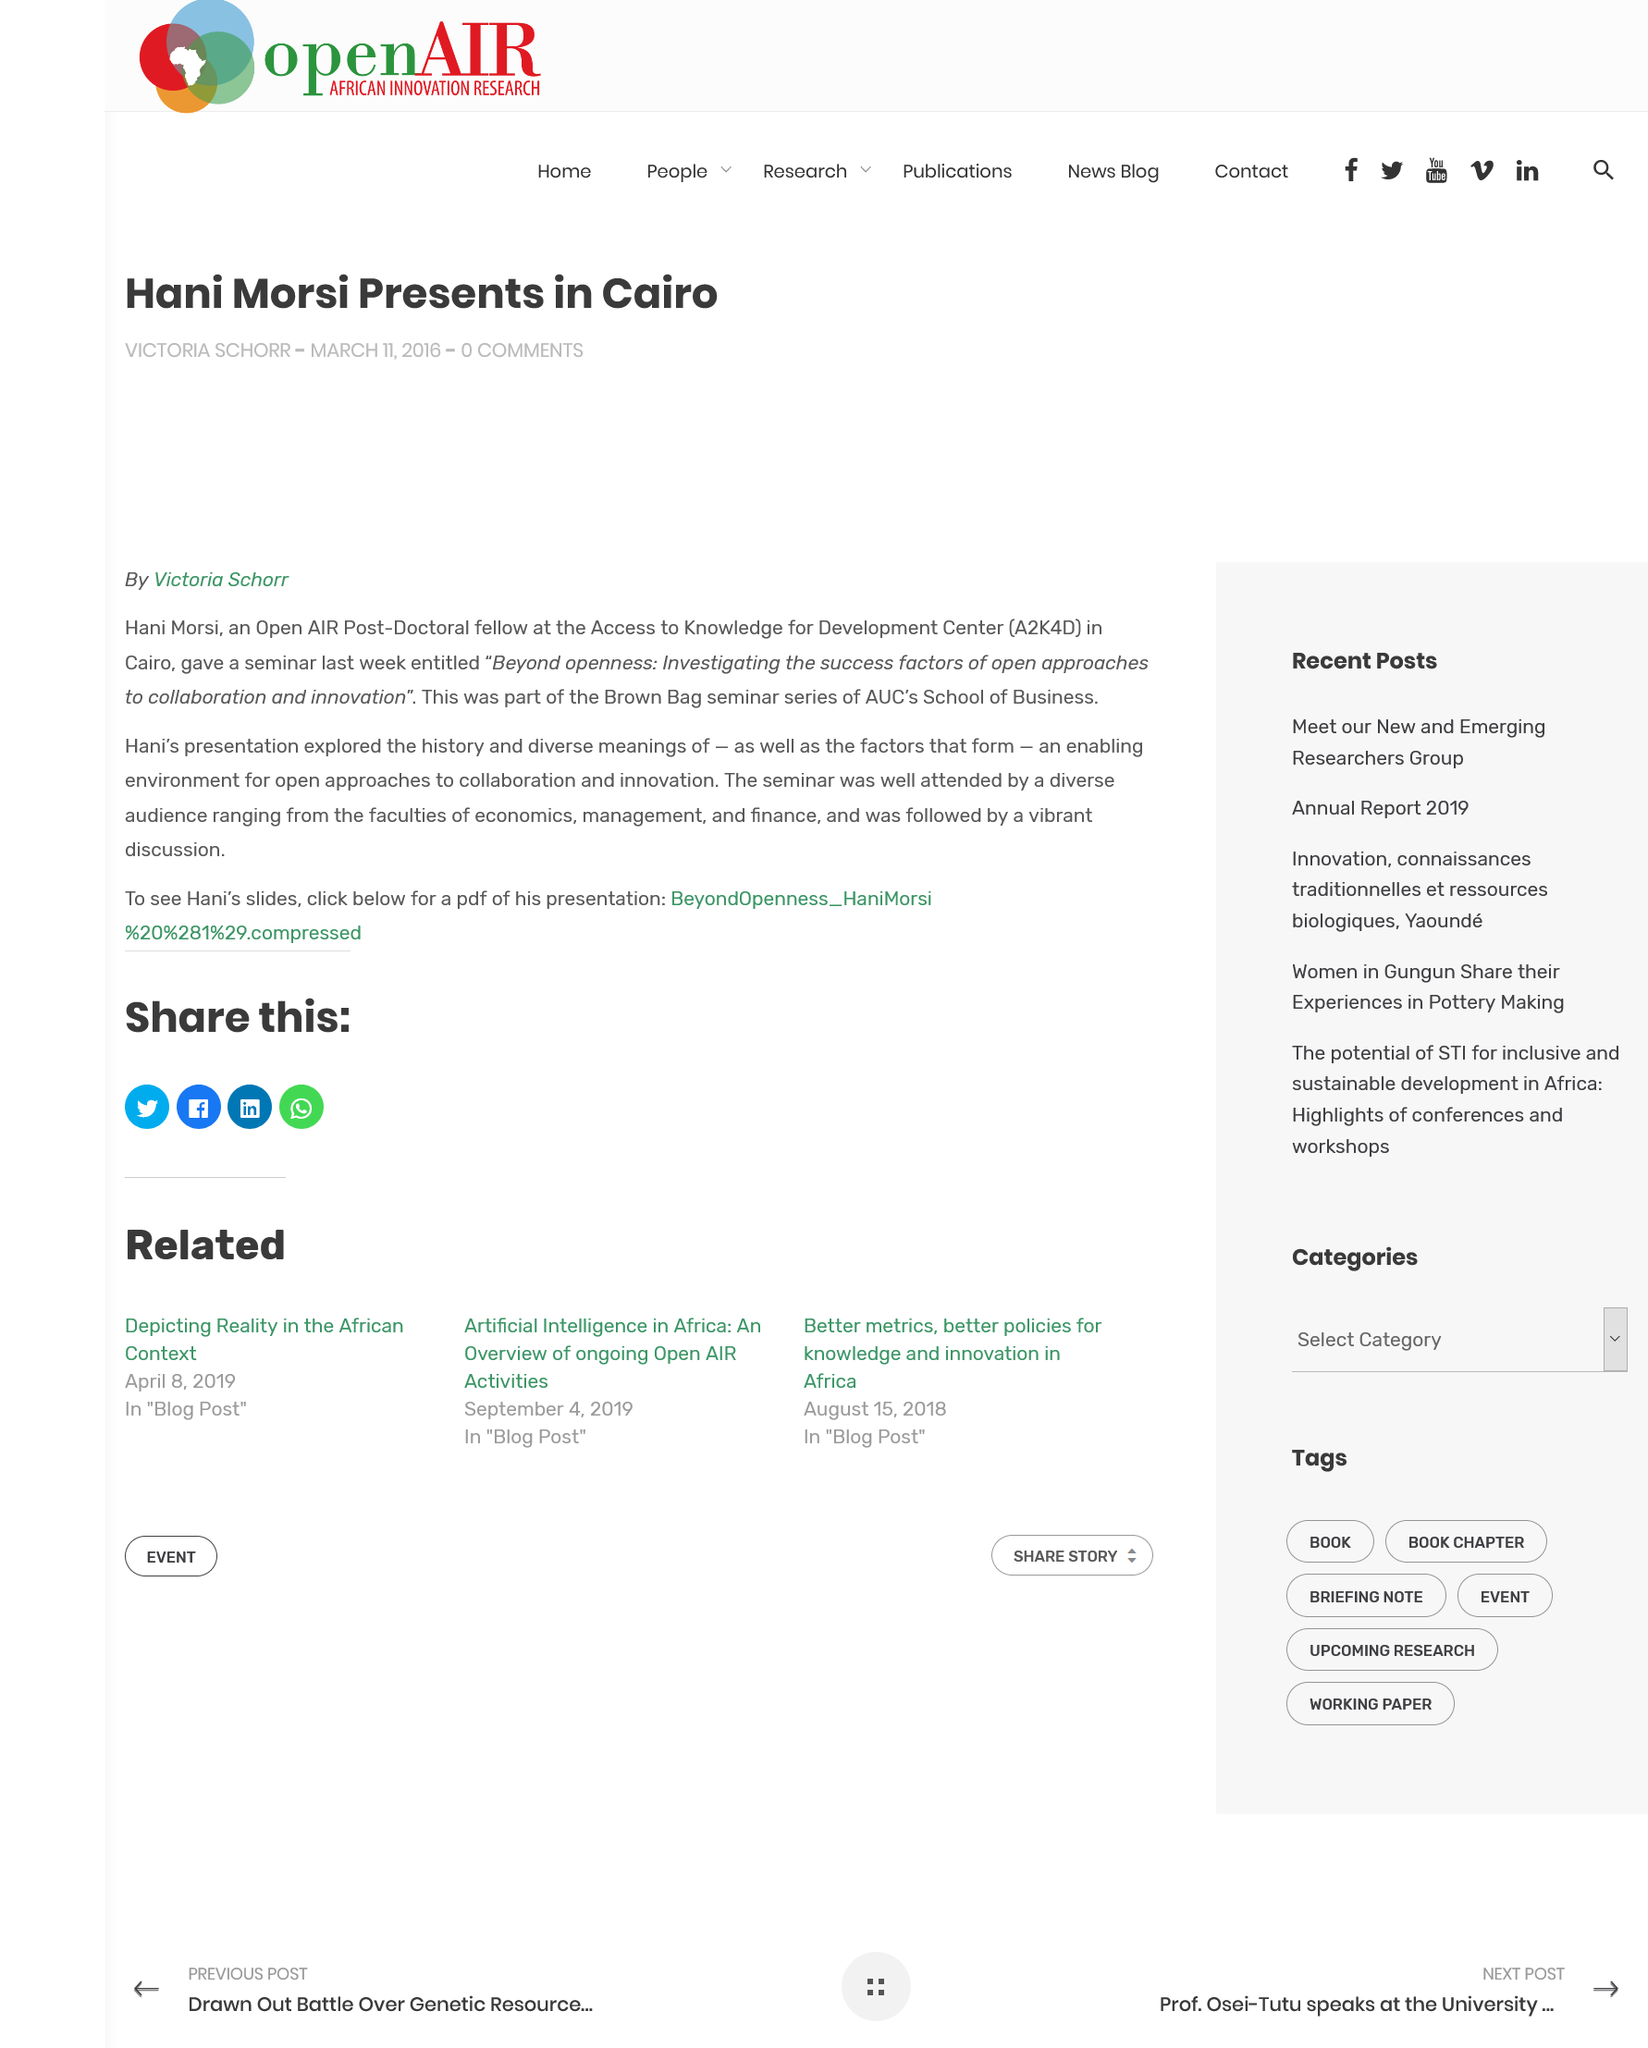Highlight a few significant elements in this photo. The seminar was attended by a diverse audience, including the faculties of economics, management, and finance. Hani Morsi is a post-doctoral fellow at the Access to Knowledge for Development Centre (A2K4D) in Cairo. Hani Morsi hosted a seminar in Cairo titled 'Beyond Openness: Investigating the Success Factors of Open Approaches to Collaboration and Innovation.' 